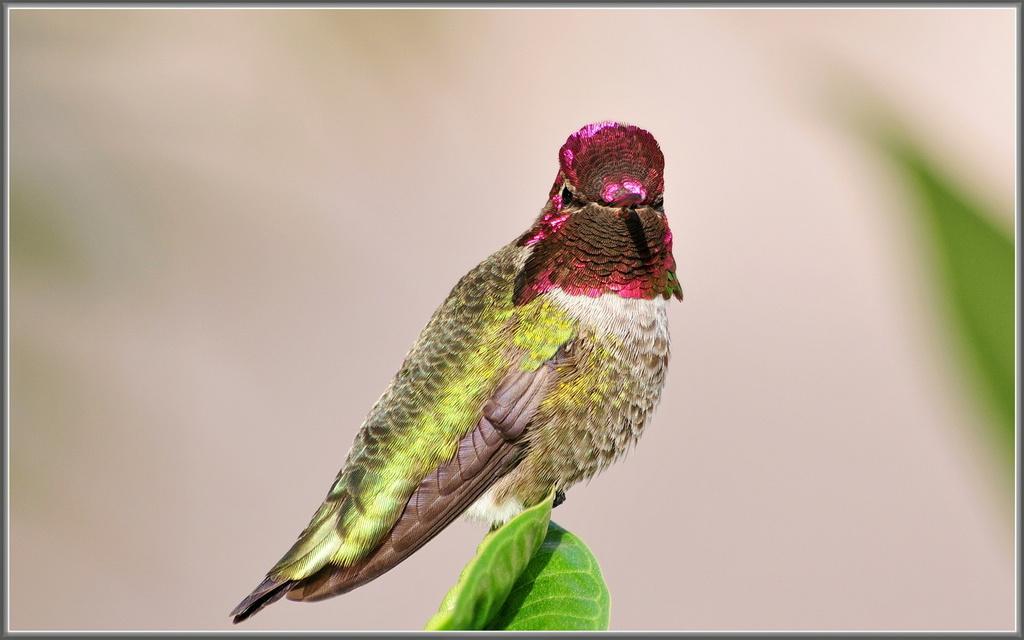How would you summarize this image in a sentence or two? This picture shows a bird on the leaf. The bird is pink green and brown in color. 